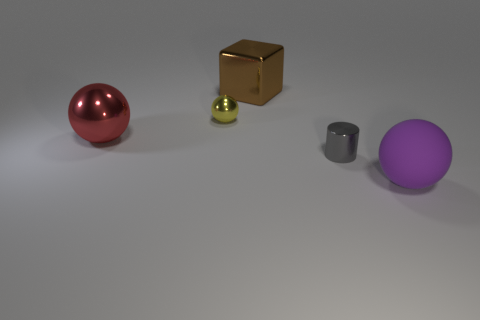Add 3 yellow shiny things. How many objects exist? 8 Subtract all purple balls. How many balls are left? 2 Subtract all big red spheres. How many spheres are left? 2 Subtract 0 blue cylinders. How many objects are left? 5 Subtract all cylinders. How many objects are left? 4 Subtract 1 cylinders. How many cylinders are left? 0 Subtract all green cylinders. Subtract all gray balls. How many cylinders are left? 1 Subtract all gray cylinders. How many yellow spheres are left? 1 Subtract all large cylinders. Subtract all brown shiny cubes. How many objects are left? 4 Add 1 large matte spheres. How many large matte spheres are left? 2 